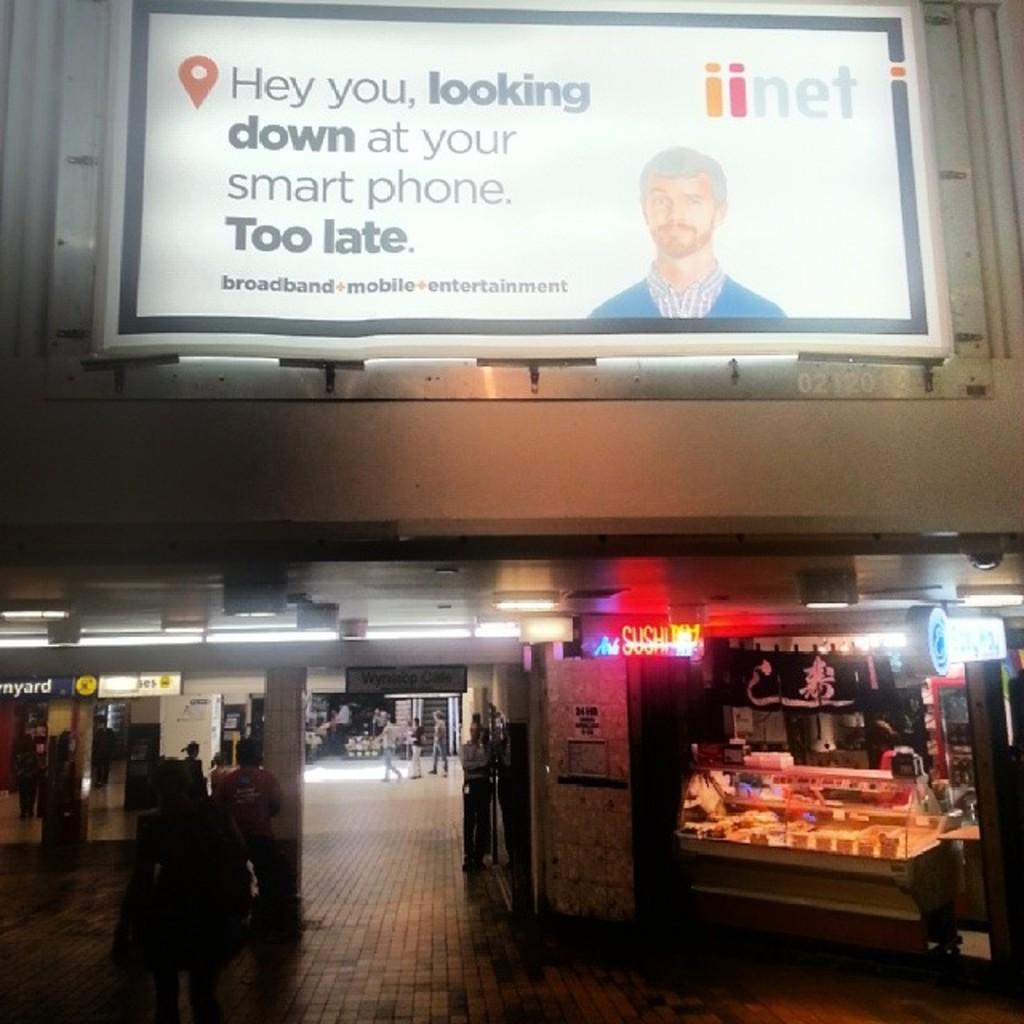What type of structure is visible in the image? There is a building in the image. What can be seen on the building in the image? There are light boards in the image. What type of establishments are present in the image? There are shops in the image. What type of illumination is present in the image? There are lights in the image. Can you describe the people in the image? There is a group of people in the image. What other objects can be seen in the image? There are other objects in the image. What type of credit can be seen being offered by the mice in the image? There are no mice present in the image, and therefore no credit can be offered by them. 